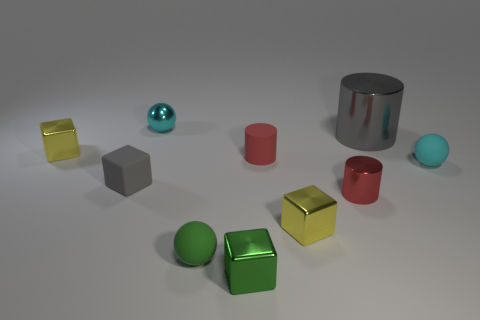Subtract all gray blocks. How many blocks are left? 3 Subtract all yellow cubes. How many red cylinders are left? 2 Subtract all gray blocks. How many blocks are left? 3 Subtract 1 blocks. How many blocks are left? 3 Subtract all brown cylinders. Subtract all brown cubes. How many cylinders are left? 3 Subtract all cubes. How many objects are left? 6 Subtract 1 cyan spheres. How many objects are left? 9 Subtract all tiny cylinders. Subtract all small red metallic cylinders. How many objects are left? 7 Add 2 gray cubes. How many gray cubes are left? 3 Add 9 red metallic cylinders. How many red metallic cylinders exist? 10 